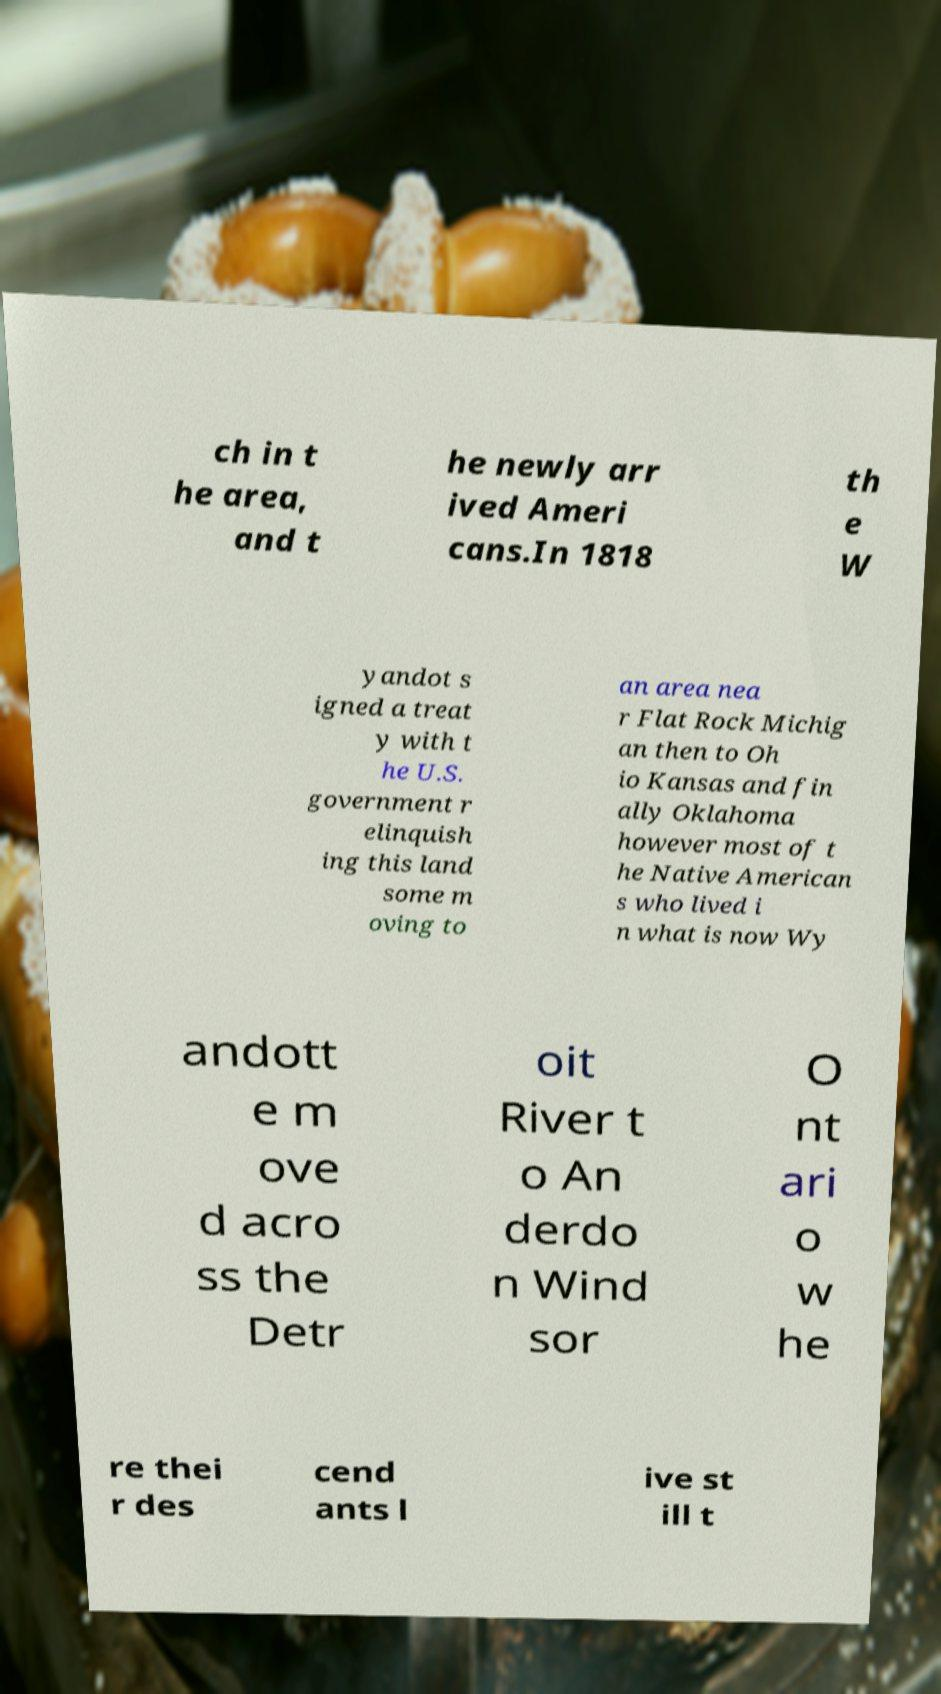Please read and relay the text visible in this image. What does it say? ch in t he area, and t he newly arr ived Ameri cans.In 1818 th e W yandot s igned a treat y with t he U.S. government r elinquish ing this land some m oving to an area nea r Flat Rock Michig an then to Oh io Kansas and fin ally Oklahoma however most of t he Native American s who lived i n what is now Wy andott e m ove d acro ss the Detr oit River t o An derdo n Wind sor O nt ari o w he re thei r des cend ants l ive st ill t 